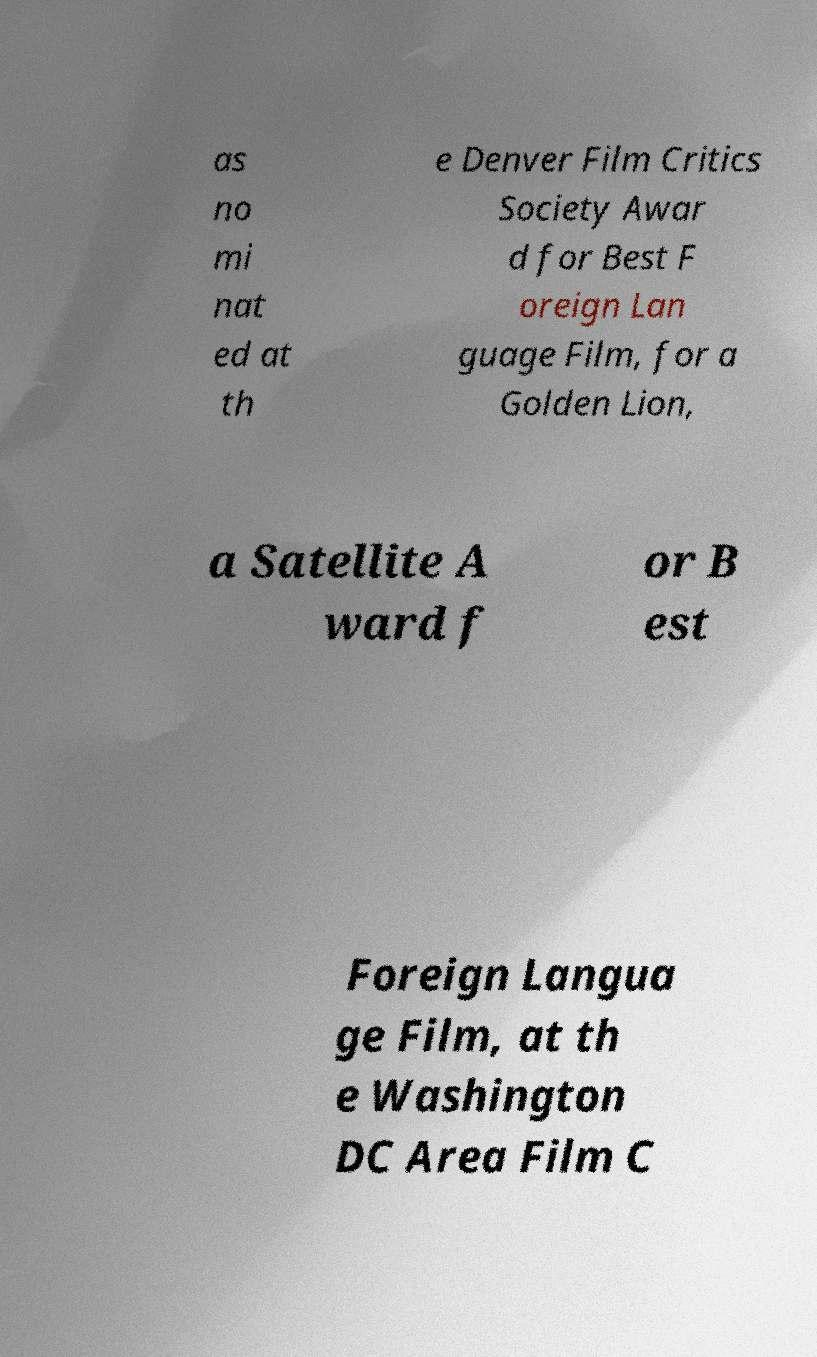Could you extract and type out the text from this image? as no mi nat ed at th e Denver Film Critics Society Awar d for Best F oreign Lan guage Film, for a Golden Lion, a Satellite A ward f or B est Foreign Langua ge Film, at th e Washington DC Area Film C 